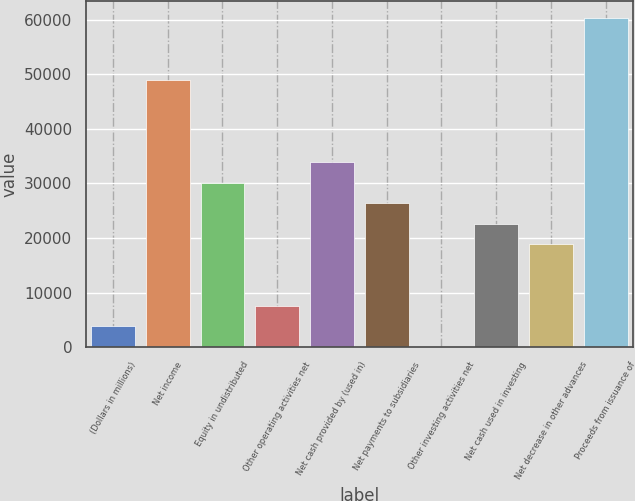Convert chart. <chart><loc_0><loc_0><loc_500><loc_500><bar_chart><fcel>(Dollars in millions)<fcel>Net income<fcel>Equity in undistributed<fcel>Other operating activities net<fcel>Net cash provided by (used in)<fcel>Net payments to subsidiaries<fcel>Other investing activities net<fcel>Net cash used in investing<fcel>Net decrease in other advances<fcel>Proceeds from issuance of<nl><fcel>3771.3<fcel>49014.9<fcel>30163.4<fcel>7541.6<fcel>33933.7<fcel>26393.1<fcel>1<fcel>22622.8<fcel>18852.5<fcel>60325.8<nl></chart> 